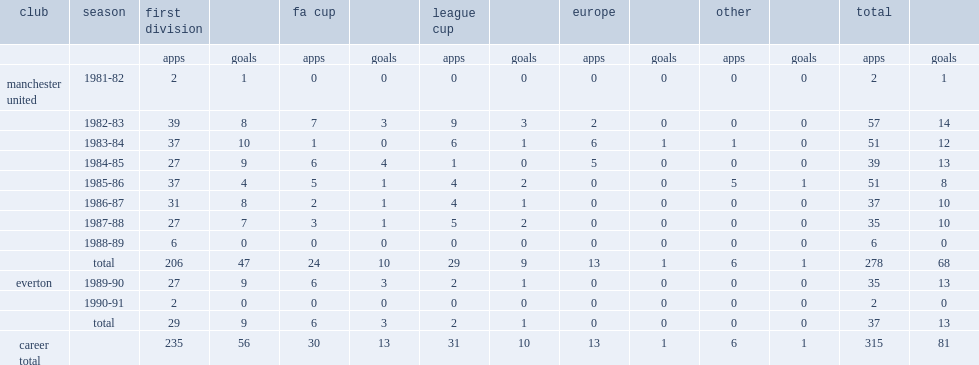How many goals did norman whiteside score for manchester united? 68.0. 